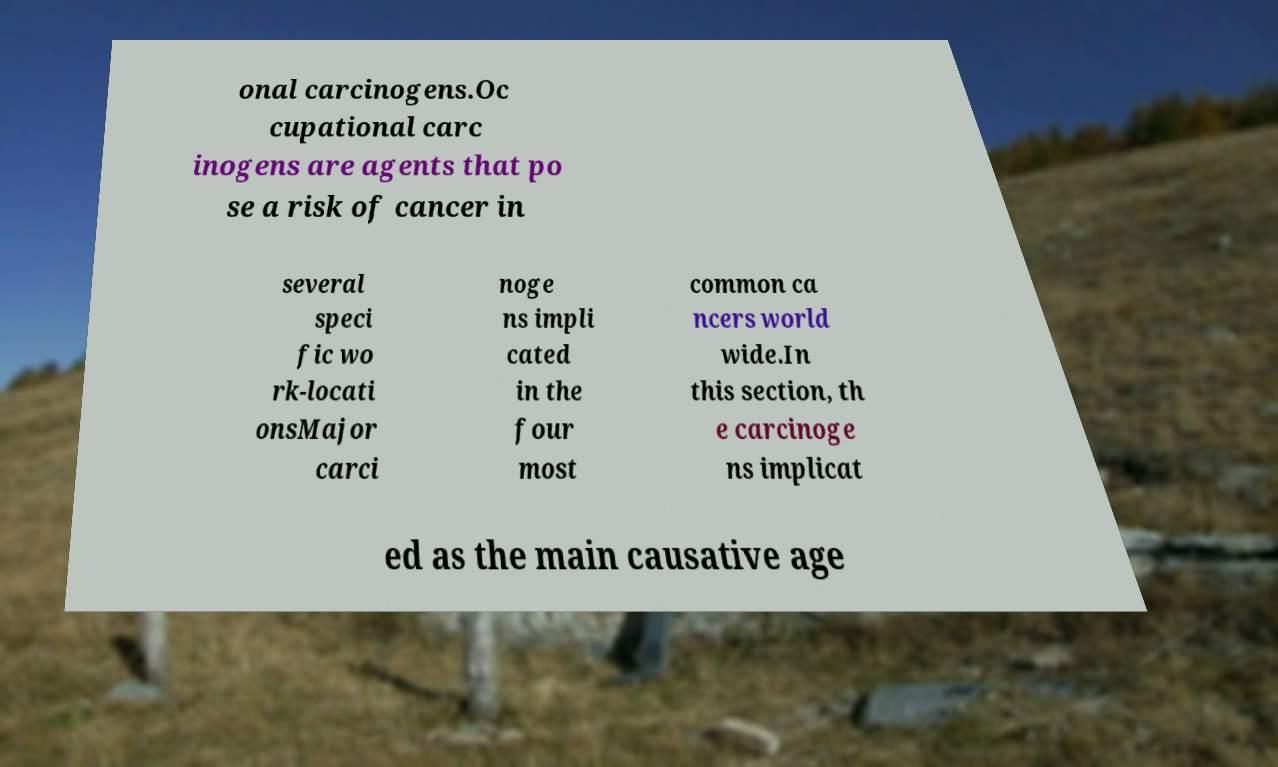I need the written content from this picture converted into text. Can you do that? onal carcinogens.Oc cupational carc inogens are agents that po se a risk of cancer in several speci fic wo rk-locati onsMajor carci noge ns impli cated in the four most common ca ncers world wide.In this section, th e carcinoge ns implicat ed as the main causative age 